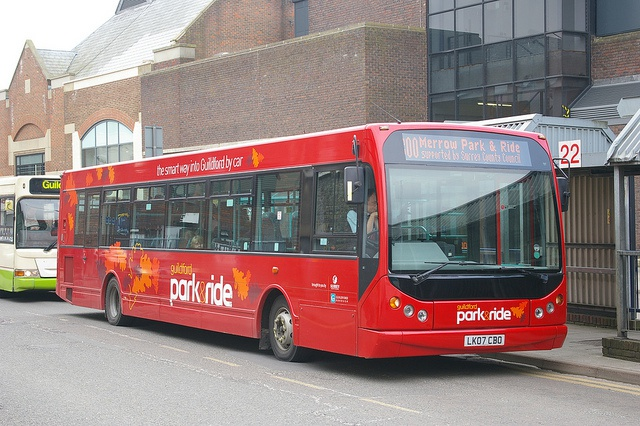Describe the objects in this image and their specific colors. I can see bus in white, gray, brown, salmon, and black tones, bus in white, ivory, darkgray, gray, and black tones, people in white, darkgray, gray, purple, and black tones, people in white, gray, darkgray, and black tones, and people in white, gray, and darkgray tones in this image. 